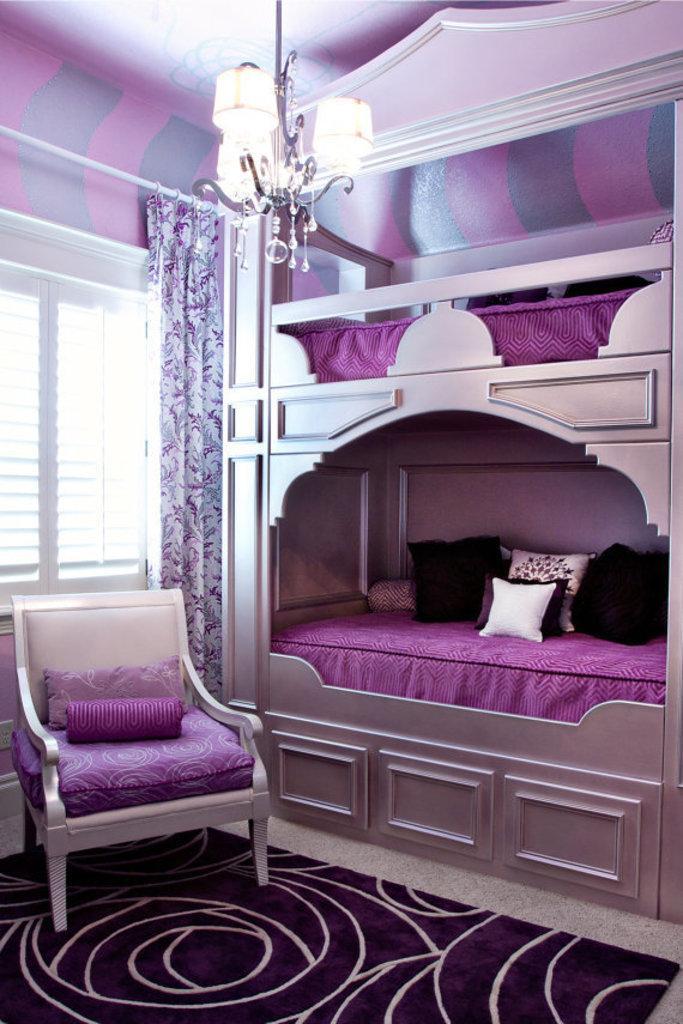Describe this image in one or two sentences. In this image we can see a pink color bed and a chair behind one window and curtain is there. Chandelier is attached to the roof of the room. Bottom of the image carpet is there. 